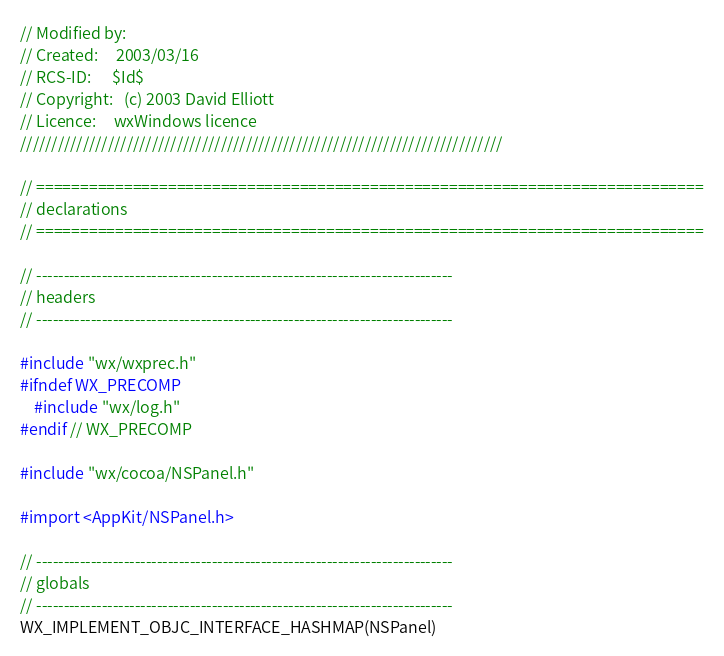<code> <loc_0><loc_0><loc_500><loc_500><_ObjectiveC_>// Modified by:
// Created:     2003/03/16
// RCS-ID:      $Id$
// Copyright:   (c) 2003 David Elliott
// Licence:     wxWindows licence
/////////////////////////////////////////////////////////////////////////////

// ============================================================================
// declarations
// ============================================================================

// ----------------------------------------------------------------------------
// headers
// ----------------------------------------------------------------------------

#include "wx/wxprec.h"
#ifndef WX_PRECOMP
    #include "wx/log.h"
#endif // WX_PRECOMP

#include "wx/cocoa/NSPanel.h"

#import <AppKit/NSPanel.h>

// ----------------------------------------------------------------------------
// globals
// ----------------------------------------------------------------------------
WX_IMPLEMENT_OBJC_INTERFACE_HASHMAP(NSPanel)
</code> 